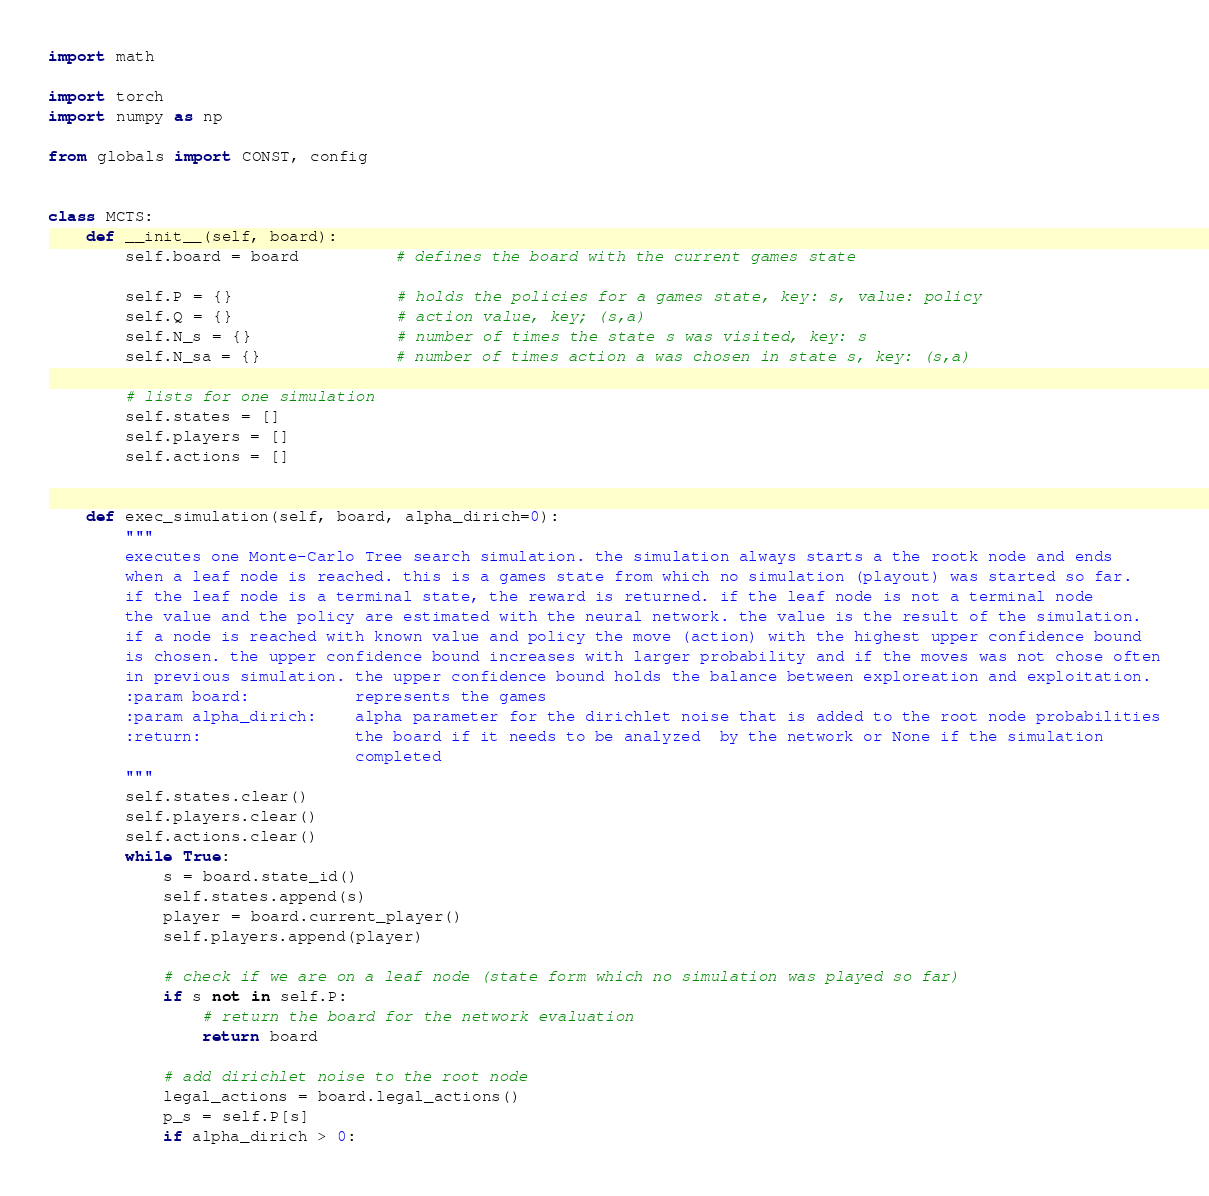Convert code to text. <code><loc_0><loc_0><loc_500><loc_500><_Python_>import math

import torch
import numpy as np

from globals import CONST, config


class MCTS:
    def __init__(self, board):
        self.board = board          # defines the board with the current games state

        self.P = {}                 # holds the policies for a games state, key: s, value: policy
        self.Q = {}                 # action value, key; (s,a)
        self.N_s = {}               # number of times the state s was visited, key: s
        self.N_sa = {}              # number of times action a was chosen in state s, key: (s,a)

        # lists for one simulation
        self.states = []
        self.players = []
        self.actions = []


    def exec_simulation(self, board, alpha_dirich=0):
        """
        executes one Monte-Carlo Tree search simulation. the simulation always starts a the rootk node and ends
        when a leaf node is reached. this is a games state from which no simulation (playout) was started so far.
        if the leaf node is a terminal state, the reward is returned. if the leaf node is not a terminal node
        the value and the policy are estimated with the neural network. the value is the result of the simulation.
        if a node is reached with known value and policy the move (action) with the highest upper confidence bound
        is chosen. the upper confidence bound increases with larger probability and if the moves was not chose often
        in previous simulation. the upper confidence bound holds the balance between exploreation and exploitation.
        :param board:           represents the games
        :param alpha_dirich:    alpha parameter for the dirichlet noise that is added to the root node probabilities
        :return:                the board if it needs to be analyzed  by the network or None if the simulation
                                completed
        """
        self.states.clear()
        self.players.clear()
        self.actions.clear()
        while True:
            s = board.state_id()
            self.states.append(s)
            player = board.current_player()
            self.players.append(player)

            # check if we are on a leaf node (state form which no simulation was played so far)
            if s not in self.P:
                # return the board for the network evaluation
                return board

            # add dirichlet noise to the root node
            legal_actions = board.legal_actions()
            p_s = self.P[s]
            if alpha_dirich > 0:</code> 